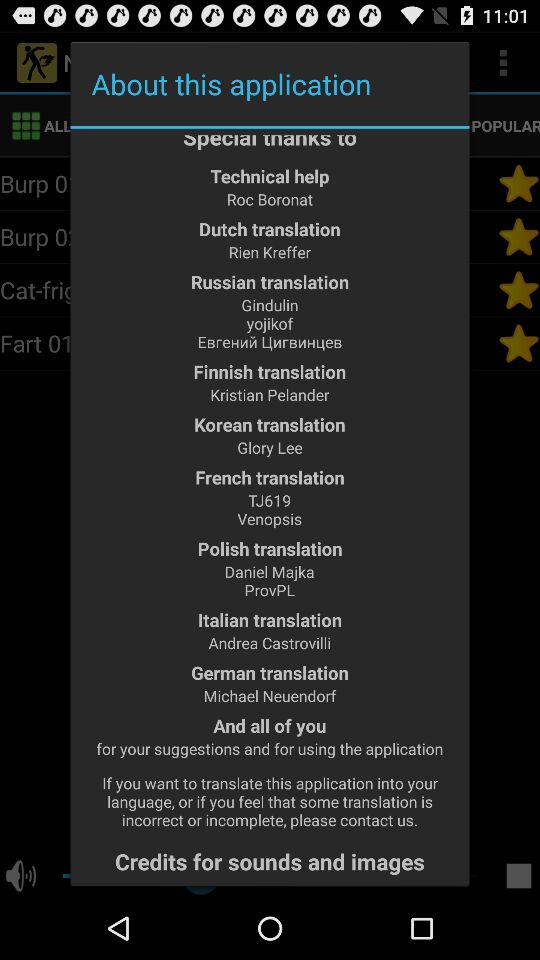What is the name of the person who translated the application into German? The name of the person is Michael Neuendorf. 